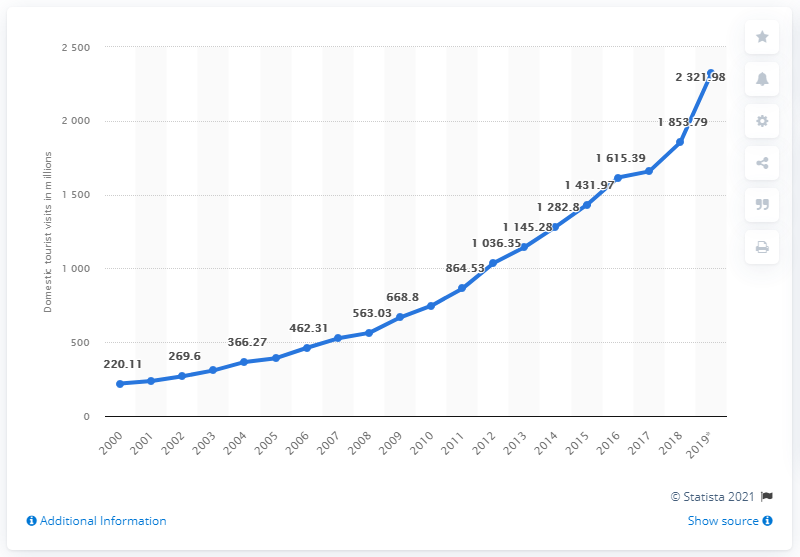Point out several critical features in this image. India experienced an exponential rise in local tourist visits in the year 2000. In 2019, there were 23,21.98 domestic tourist visits made in India. 